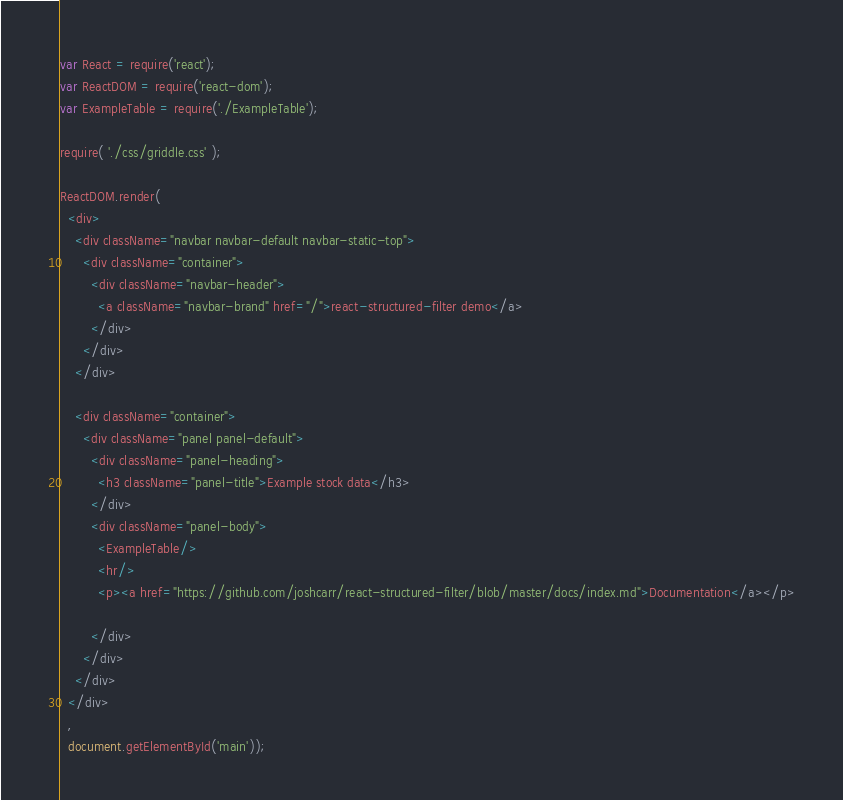<code> <loc_0><loc_0><loc_500><loc_500><_JavaScript_>var React = require('react');
var ReactDOM = require('react-dom');
var ExampleTable = require('./ExampleTable');

require( './css/griddle.css' );

ReactDOM.render(
  <div>
    <div className="navbar navbar-default navbar-static-top">
      <div className="container">
        <div className="navbar-header">
          <a className="navbar-brand" href="/">react-structured-filter demo</a>
        </div>
      </div>
    </div>

    <div className="container">
      <div className="panel panel-default">
        <div className="panel-heading">
          <h3 className="panel-title">Example stock data</h3>
        </div>
        <div className="panel-body">
          <ExampleTable/>
          <hr/>
          <p><a href="https://github.com/joshcarr/react-structured-filter/blob/master/docs/index.md">Documentation</a></p>

        </div>
      </div>
    </div>
  </div>
  ,
  document.getElementById('main'));
</code> 